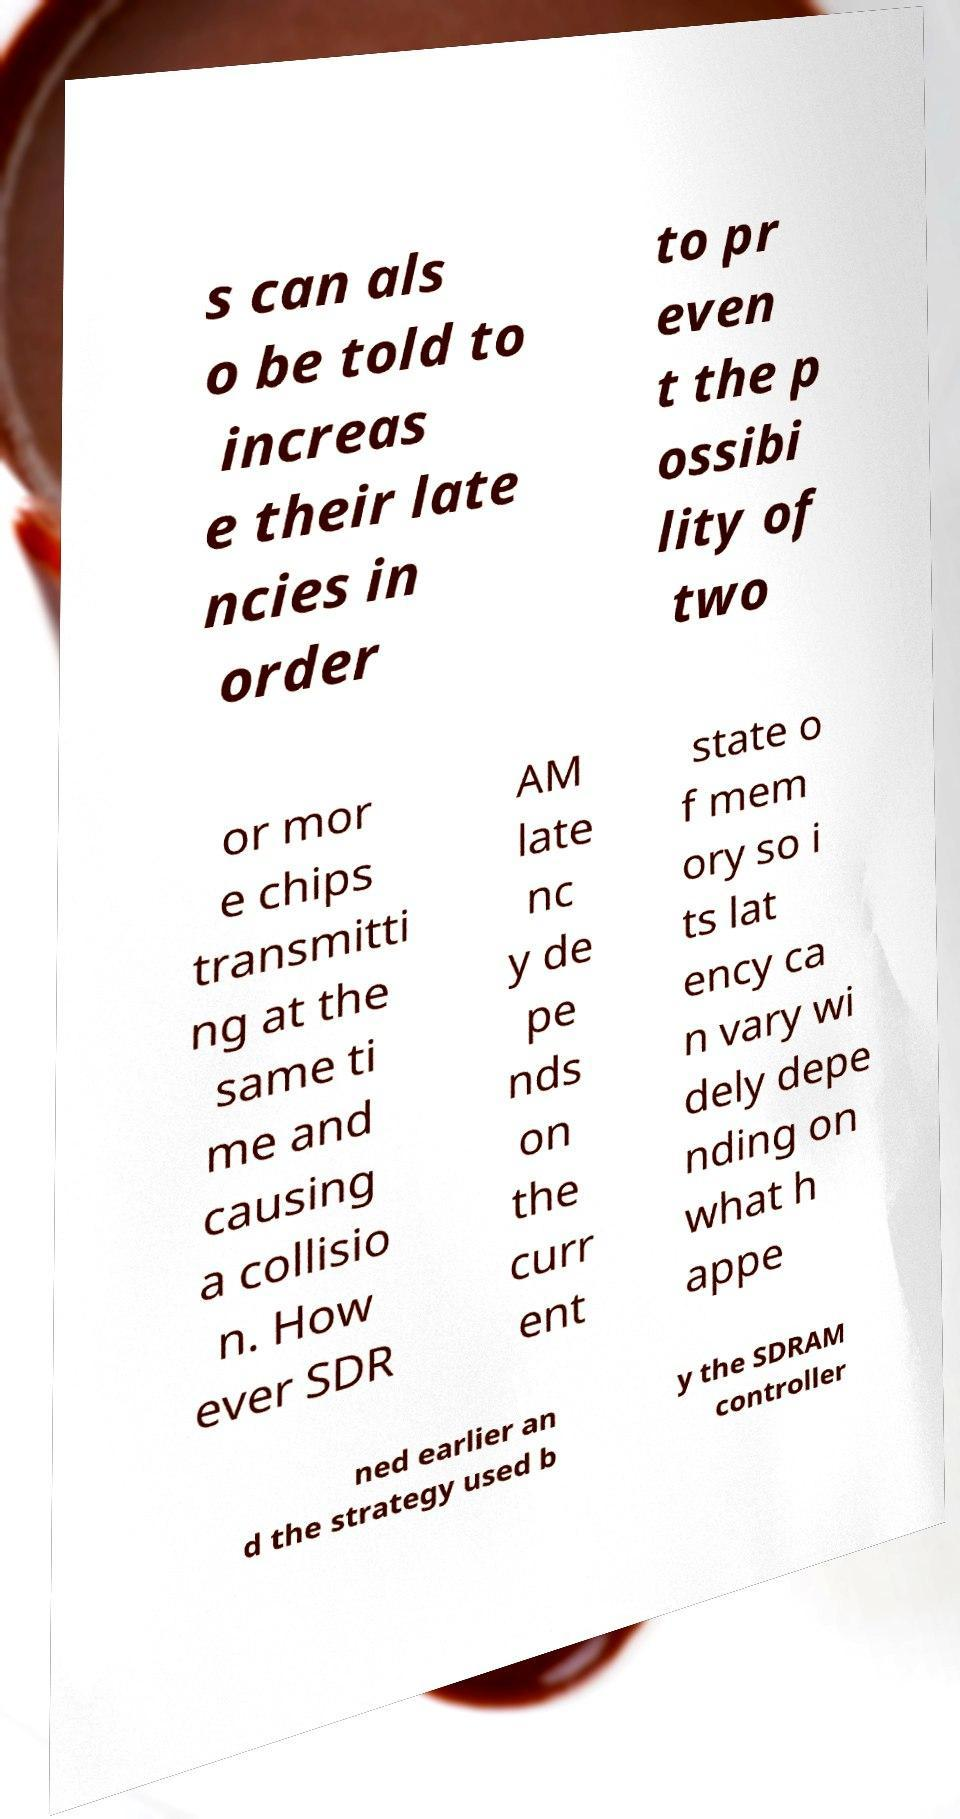Can you accurately transcribe the text from the provided image for me? s can als o be told to increas e their late ncies in order to pr even t the p ossibi lity of two or mor e chips transmitti ng at the same ti me and causing a collisio n. How ever SDR AM late nc y de pe nds on the curr ent state o f mem ory so i ts lat ency ca n vary wi dely depe nding on what h appe ned earlier an d the strategy used b y the SDRAM controller 